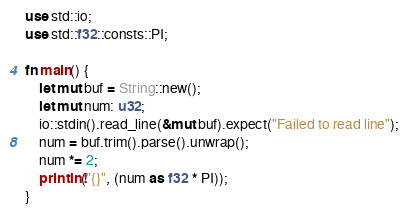<code> <loc_0><loc_0><loc_500><loc_500><_Rust_>use std::io;
use std::f32::consts::PI;

fn main() {
    let mut buf = String::new();
    let mut num: u32;
    io::stdin().read_line(&mut buf).expect("Failed to read line");
    num = buf.trim().parse().unwrap();
    num *= 2;
    println!("{}", (num as f32 * PI));
}
</code> 